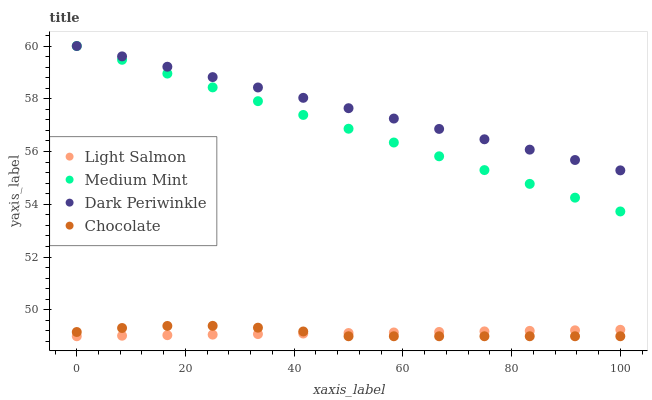Does Light Salmon have the minimum area under the curve?
Answer yes or no. Yes. Does Dark Periwinkle have the maximum area under the curve?
Answer yes or no. Yes. Does Dark Periwinkle have the minimum area under the curve?
Answer yes or no. No. Does Light Salmon have the maximum area under the curve?
Answer yes or no. No. Is Dark Periwinkle the smoothest?
Answer yes or no. Yes. Is Chocolate the roughest?
Answer yes or no. Yes. Is Light Salmon the smoothest?
Answer yes or no. No. Is Light Salmon the roughest?
Answer yes or no. No. Does Light Salmon have the lowest value?
Answer yes or no. Yes. Does Dark Periwinkle have the lowest value?
Answer yes or no. No. Does Dark Periwinkle have the highest value?
Answer yes or no. Yes. Does Light Salmon have the highest value?
Answer yes or no. No. Is Light Salmon less than Medium Mint?
Answer yes or no. Yes. Is Medium Mint greater than Chocolate?
Answer yes or no. Yes. Does Medium Mint intersect Dark Periwinkle?
Answer yes or no. Yes. Is Medium Mint less than Dark Periwinkle?
Answer yes or no. No. Is Medium Mint greater than Dark Periwinkle?
Answer yes or no. No. Does Light Salmon intersect Medium Mint?
Answer yes or no. No. 